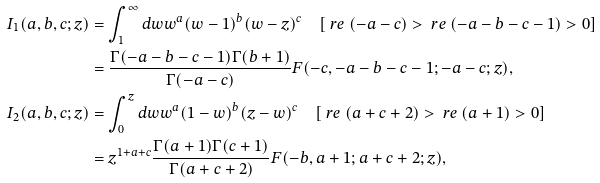Convert formula to latex. <formula><loc_0><loc_0><loc_500><loc_500>I _ { 1 } ( a , b , c ; z ) & = \int ^ { \infty } _ { 1 } d w w ^ { a } ( w - 1 ) ^ { b } ( w - z ) ^ { c } \quad [ \ r e \ ( - a - c ) > \ r e \ ( - a - b - c - 1 ) > 0 ] \\ & = \frac { \Gamma ( - a - b - c - 1 ) \Gamma ( b + 1 ) } { \Gamma ( - a - c ) } F ( - c , - a - b - c - 1 ; - a - c ; z ) , \\ I _ { 2 } ( a , b , c ; z ) & = \int ^ { z } _ { 0 } d w w ^ { a } ( 1 - w ) ^ { b } ( z - w ) ^ { c } \quad [ \ r e \ ( a + c + 2 ) > \ r e \ ( a + 1 ) > 0 ] \\ & = z ^ { 1 + a + c } \frac { \Gamma ( a + 1 ) \Gamma ( c + 1 ) } { \Gamma ( a + c + 2 ) } F ( - b , a + 1 ; a + c + 2 ; z ) ,</formula> 